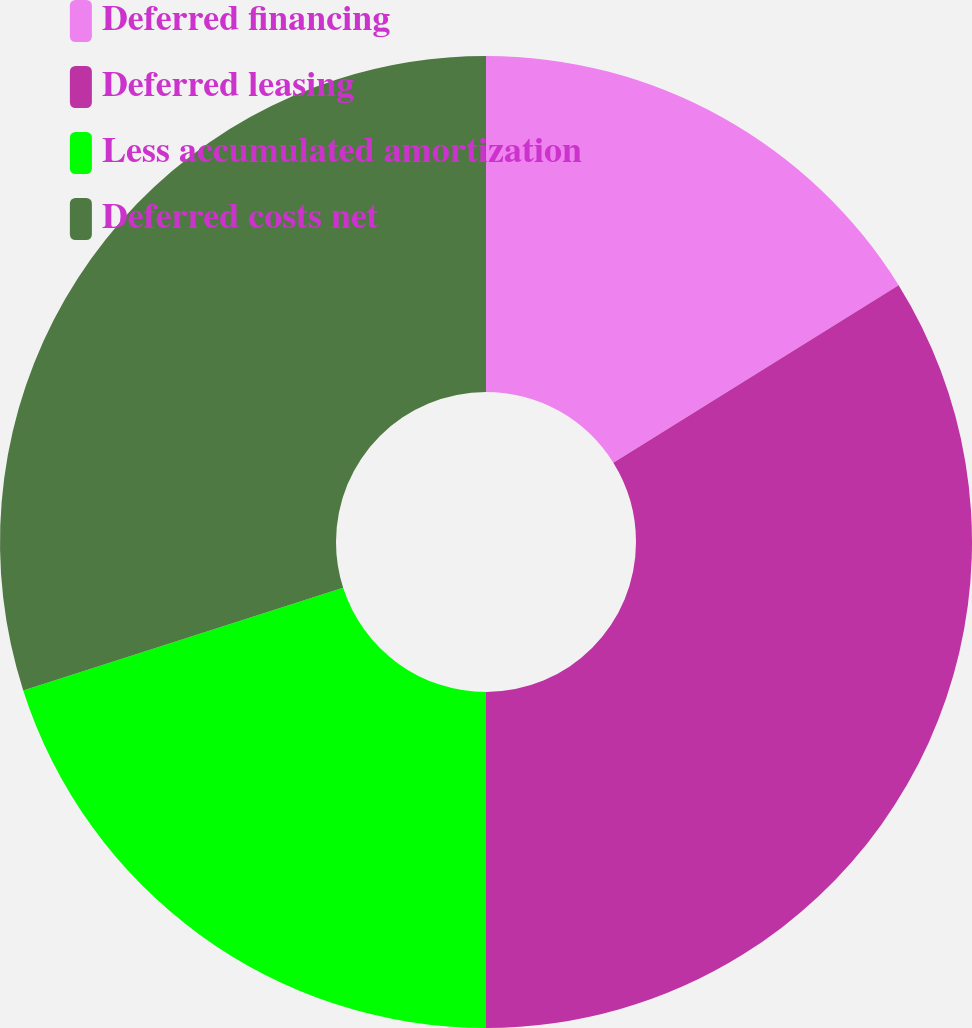<chart> <loc_0><loc_0><loc_500><loc_500><pie_chart><fcel>Deferred financing<fcel>Deferred leasing<fcel>Less accumulated amortization<fcel>Deferred costs net<nl><fcel>16.14%<fcel>33.86%<fcel>20.06%<fcel>29.94%<nl></chart> 